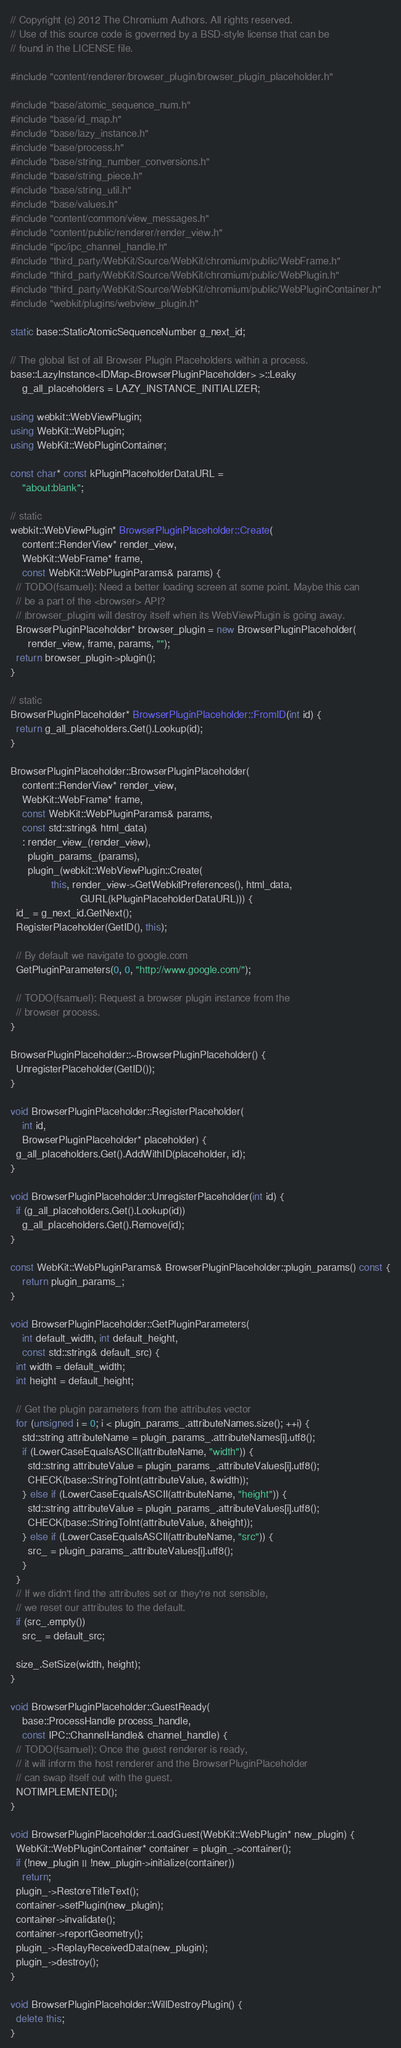Convert code to text. <code><loc_0><loc_0><loc_500><loc_500><_C++_>// Copyright (c) 2012 The Chromium Authors. All rights reserved.
// Use of this source code is governed by a BSD-style license that can be
// found in the LICENSE file.

#include "content/renderer/browser_plugin/browser_plugin_placeholder.h"

#include "base/atomic_sequence_num.h"
#include "base/id_map.h"
#include "base/lazy_instance.h"
#include "base/process.h"
#include "base/string_number_conversions.h"
#include "base/string_piece.h"
#include "base/string_util.h"
#include "base/values.h"
#include "content/common/view_messages.h"
#include "content/public/renderer/render_view.h"
#include "ipc/ipc_channel_handle.h"
#include "third_party/WebKit/Source/WebKit/chromium/public/WebFrame.h"
#include "third_party/WebKit/Source/WebKit/chromium/public/WebPlugin.h"
#include "third_party/WebKit/Source/WebKit/chromium/public/WebPluginContainer.h"
#include "webkit/plugins/webview_plugin.h"

static base::StaticAtomicSequenceNumber g_next_id;

// The global list of all Browser Plugin Placeholders within a process.
base::LazyInstance<IDMap<BrowserPluginPlaceholder> >::Leaky
    g_all_placeholders = LAZY_INSTANCE_INITIALIZER;

using webkit::WebViewPlugin;
using WebKit::WebPlugin;
using WebKit::WebPluginContainer;

const char* const kPluginPlaceholderDataURL =
    "about:blank";

// static
webkit::WebViewPlugin* BrowserPluginPlaceholder::Create(
    content::RenderView* render_view,
    WebKit::WebFrame* frame,
    const WebKit::WebPluginParams& params) {
  // TODO(fsamuel): Need a better loading screen at some point. Maybe this can
  // be a part of the <browser> API?
  // |browser_plugin| will destroy itself when its WebViewPlugin is going away.
  BrowserPluginPlaceholder* browser_plugin = new BrowserPluginPlaceholder(
      render_view, frame, params, "");
  return browser_plugin->plugin();
}

// static
BrowserPluginPlaceholder* BrowserPluginPlaceholder::FromID(int id) {
  return g_all_placeholders.Get().Lookup(id);
}

BrowserPluginPlaceholder::BrowserPluginPlaceholder(
    content::RenderView* render_view,
    WebKit::WebFrame* frame,
    const WebKit::WebPluginParams& params,
    const std::string& html_data)
    : render_view_(render_view),
      plugin_params_(params),
      plugin_(webkit::WebViewPlugin::Create(
              this, render_view->GetWebkitPreferences(), html_data,
                        GURL(kPluginPlaceholderDataURL))) {
  id_ = g_next_id.GetNext();
  RegisterPlaceholder(GetID(), this);

  // By default we navigate to google.com
  GetPluginParameters(0, 0, "http://www.google.com/");

  // TODO(fsamuel): Request a browser plugin instance from the
  // browser process.
}

BrowserPluginPlaceholder::~BrowserPluginPlaceholder() {
  UnregisterPlaceholder(GetID());
}

void BrowserPluginPlaceholder::RegisterPlaceholder(
    int id,
    BrowserPluginPlaceholder* placeholder) {
  g_all_placeholders.Get().AddWithID(placeholder, id);
}

void BrowserPluginPlaceholder::UnregisterPlaceholder(int id) {
  if (g_all_placeholders.Get().Lookup(id))
    g_all_placeholders.Get().Remove(id);
}

const WebKit::WebPluginParams& BrowserPluginPlaceholder::plugin_params() const {
    return plugin_params_;
}

void BrowserPluginPlaceholder::GetPluginParameters(
    int default_width, int default_height,
    const std::string& default_src) {
  int width = default_width;
  int height = default_height;

  // Get the plugin parameters from the attributes vector
  for (unsigned i = 0; i < plugin_params_.attributeNames.size(); ++i) {
    std::string attributeName = plugin_params_.attributeNames[i].utf8();
    if (LowerCaseEqualsASCII(attributeName, "width")) {
      std::string attributeValue = plugin_params_.attributeValues[i].utf8();
      CHECK(base::StringToInt(attributeValue, &width));
    } else if (LowerCaseEqualsASCII(attributeName, "height")) {
      std::string attributeValue = plugin_params_.attributeValues[i].utf8();
      CHECK(base::StringToInt(attributeValue, &height));
    } else if (LowerCaseEqualsASCII(attributeName, "src")) {
      src_ = plugin_params_.attributeValues[i].utf8();
    }
  }
  // If we didn't find the attributes set or they're not sensible,
  // we reset our attributes to the default.
  if (src_.empty())
    src_ = default_src;

  size_.SetSize(width, height);
}

void BrowserPluginPlaceholder::GuestReady(
    base::ProcessHandle process_handle,
    const IPC::ChannelHandle& channel_handle) {
  // TODO(fsamuel): Once the guest renderer is ready,
  // it will inform the host renderer and the BrowserPluginPlaceholder
  // can swap itself out with the guest.
  NOTIMPLEMENTED();
}

void BrowserPluginPlaceholder::LoadGuest(WebKit::WebPlugin* new_plugin) {
  WebKit::WebPluginContainer* container = plugin_->container();
  if (!new_plugin || !new_plugin->initialize(container))
    return;
  plugin_->RestoreTitleText();
  container->setPlugin(new_plugin);
  container->invalidate();
  container->reportGeometry();
  plugin_->ReplayReceivedData(new_plugin);
  plugin_->destroy();
}

void BrowserPluginPlaceholder::WillDestroyPlugin() {
  delete this;
}
</code> 